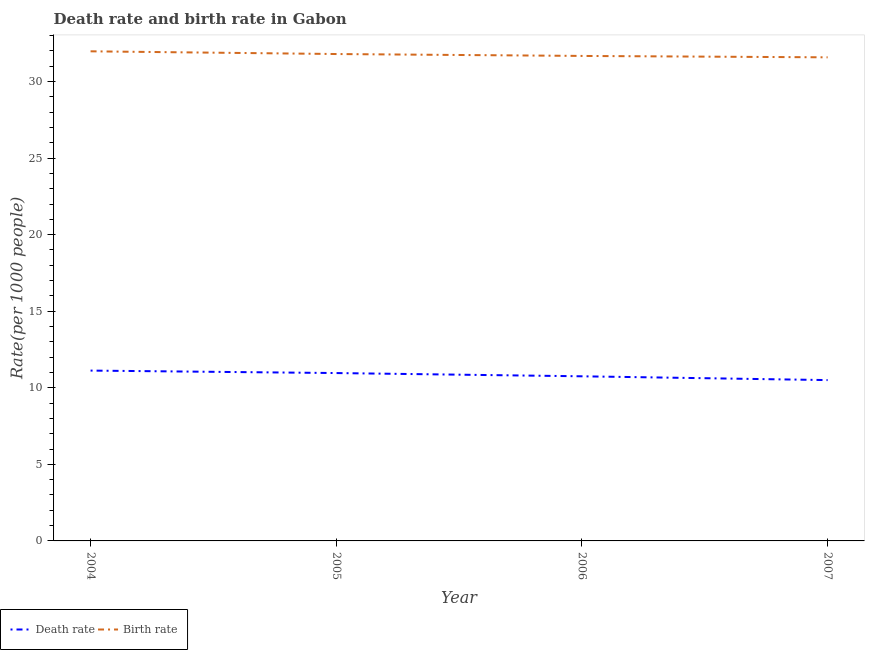How many different coloured lines are there?
Provide a short and direct response. 2. Is the number of lines equal to the number of legend labels?
Make the answer very short. Yes. What is the birth rate in 2006?
Ensure brevity in your answer.  31.67. Across all years, what is the maximum birth rate?
Make the answer very short. 31.98. Across all years, what is the minimum death rate?
Give a very brief answer. 10.5. In which year was the death rate maximum?
Provide a short and direct response. 2004. What is the total death rate in the graph?
Your answer should be very brief. 43.34. What is the difference between the birth rate in 2006 and that in 2007?
Keep it short and to the point. 0.09. What is the difference between the death rate in 2007 and the birth rate in 2005?
Offer a terse response. -21.29. What is the average birth rate per year?
Your answer should be very brief. 31.76. In the year 2004, what is the difference between the birth rate and death rate?
Ensure brevity in your answer.  20.85. In how many years, is the death rate greater than 11?
Make the answer very short. 1. What is the ratio of the death rate in 2005 to that in 2006?
Ensure brevity in your answer.  1.02. Is the death rate in 2004 less than that in 2007?
Provide a short and direct response. No. Is the difference between the birth rate in 2005 and 2007 greater than the difference between the death rate in 2005 and 2007?
Keep it short and to the point. No. What is the difference between the highest and the second highest birth rate?
Offer a terse response. 0.18. What is the difference between the highest and the lowest birth rate?
Your answer should be compact. 0.39. In how many years, is the birth rate greater than the average birth rate taken over all years?
Keep it short and to the point. 2. Is the sum of the death rate in 2004 and 2005 greater than the maximum birth rate across all years?
Keep it short and to the point. No. Does the death rate monotonically increase over the years?
Offer a very short reply. No. Is the birth rate strictly greater than the death rate over the years?
Provide a succinct answer. Yes. Is the birth rate strictly less than the death rate over the years?
Give a very brief answer. No. How many lines are there?
Make the answer very short. 2. How many years are there in the graph?
Provide a succinct answer. 4. Are the values on the major ticks of Y-axis written in scientific E-notation?
Make the answer very short. No. Does the graph contain any zero values?
Make the answer very short. No. Where does the legend appear in the graph?
Your response must be concise. Bottom left. How many legend labels are there?
Your answer should be compact. 2. What is the title of the graph?
Your response must be concise. Death rate and birth rate in Gabon. What is the label or title of the X-axis?
Your answer should be compact. Year. What is the label or title of the Y-axis?
Offer a terse response. Rate(per 1000 people). What is the Rate(per 1000 people) of Death rate in 2004?
Offer a terse response. 11.12. What is the Rate(per 1000 people) of Birth rate in 2004?
Ensure brevity in your answer.  31.98. What is the Rate(per 1000 people) of Death rate in 2005?
Provide a short and direct response. 10.96. What is the Rate(per 1000 people) of Birth rate in 2005?
Your response must be concise. 31.8. What is the Rate(per 1000 people) in Death rate in 2006?
Keep it short and to the point. 10.75. What is the Rate(per 1000 people) of Birth rate in 2006?
Provide a succinct answer. 31.67. What is the Rate(per 1000 people) in Death rate in 2007?
Make the answer very short. 10.5. What is the Rate(per 1000 people) in Birth rate in 2007?
Provide a short and direct response. 31.58. Across all years, what is the maximum Rate(per 1000 people) in Death rate?
Offer a terse response. 11.12. Across all years, what is the maximum Rate(per 1000 people) of Birth rate?
Your answer should be very brief. 31.98. Across all years, what is the minimum Rate(per 1000 people) in Death rate?
Give a very brief answer. 10.5. Across all years, what is the minimum Rate(per 1000 people) in Birth rate?
Offer a terse response. 31.58. What is the total Rate(per 1000 people) of Death rate in the graph?
Your response must be concise. 43.34. What is the total Rate(per 1000 people) of Birth rate in the graph?
Your answer should be very brief. 127.03. What is the difference between the Rate(per 1000 people) of Death rate in 2004 and that in 2005?
Offer a terse response. 0.16. What is the difference between the Rate(per 1000 people) of Birth rate in 2004 and that in 2005?
Keep it short and to the point. 0.18. What is the difference between the Rate(per 1000 people) in Death rate in 2004 and that in 2006?
Give a very brief answer. 0.37. What is the difference between the Rate(per 1000 people) in Birth rate in 2004 and that in 2006?
Provide a succinct answer. 0.3. What is the difference between the Rate(per 1000 people) in Death rate in 2004 and that in 2007?
Ensure brevity in your answer.  0.62. What is the difference between the Rate(per 1000 people) of Birth rate in 2004 and that in 2007?
Give a very brief answer. 0.39. What is the difference between the Rate(per 1000 people) in Death rate in 2005 and that in 2006?
Provide a short and direct response. 0.21. What is the difference between the Rate(per 1000 people) in Death rate in 2005 and that in 2007?
Keep it short and to the point. 0.46. What is the difference between the Rate(per 1000 people) of Birth rate in 2005 and that in 2007?
Make the answer very short. 0.22. What is the difference between the Rate(per 1000 people) in Death rate in 2006 and that in 2007?
Provide a short and direct response. 0.25. What is the difference between the Rate(per 1000 people) in Birth rate in 2006 and that in 2007?
Keep it short and to the point. 0.09. What is the difference between the Rate(per 1000 people) in Death rate in 2004 and the Rate(per 1000 people) in Birth rate in 2005?
Your response must be concise. -20.67. What is the difference between the Rate(per 1000 people) of Death rate in 2004 and the Rate(per 1000 people) of Birth rate in 2006?
Offer a very short reply. -20.55. What is the difference between the Rate(per 1000 people) in Death rate in 2004 and the Rate(per 1000 people) in Birth rate in 2007?
Give a very brief answer. -20.46. What is the difference between the Rate(per 1000 people) of Death rate in 2005 and the Rate(per 1000 people) of Birth rate in 2006?
Ensure brevity in your answer.  -20.71. What is the difference between the Rate(per 1000 people) of Death rate in 2005 and the Rate(per 1000 people) of Birth rate in 2007?
Provide a short and direct response. -20.62. What is the difference between the Rate(per 1000 people) of Death rate in 2006 and the Rate(per 1000 people) of Birth rate in 2007?
Offer a terse response. -20.83. What is the average Rate(per 1000 people) of Death rate per year?
Give a very brief answer. 10.84. What is the average Rate(per 1000 people) in Birth rate per year?
Make the answer very short. 31.76. In the year 2004, what is the difference between the Rate(per 1000 people) of Death rate and Rate(per 1000 people) of Birth rate?
Provide a succinct answer. -20.85. In the year 2005, what is the difference between the Rate(per 1000 people) in Death rate and Rate(per 1000 people) in Birth rate?
Ensure brevity in your answer.  -20.84. In the year 2006, what is the difference between the Rate(per 1000 people) in Death rate and Rate(per 1000 people) in Birth rate?
Your answer should be very brief. -20.92. In the year 2007, what is the difference between the Rate(per 1000 people) of Death rate and Rate(per 1000 people) of Birth rate?
Ensure brevity in your answer.  -21.08. What is the ratio of the Rate(per 1000 people) of Death rate in 2004 to that in 2005?
Offer a terse response. 1.01. What is the ratio of the Rate(per 1000 people) of Birth rate in 2004 to that in 2005?
Give a very brief answer. 1.01. What is the ratio of the Rate(per 1000 people) of Death rate in 2004 to that in 2006?
Offer a very short reply. 1.03. What is the ratio of the Rate(per 1000 people) in Birth rate in 2004 to that in 2006?
Keep it short and to the point. 1.01. What is the ratio of the Rate(per 1000 people) in Death rate in 2004 to that in 2007?
Ensure brevity in your answer.  1.06. What is the ratio of the Rate(per 1000 people) of Birth rate in 2004 to that in 2007?
Provide a short and direct response. 1.01. What is the ratio of the Rate(per 1000 people) of Death rate in 2005 to that in 2006?
Give a very brief answer. 1.02. What is the ratio of the Rate(per 1000 people) of Death rate in 2005 to that in 2007?
Provide a succinct answer. 1.04. What is the ratio of the Rate(per 1000 people) in Birth rate in 2005 to that in 2007?
Offer a very short reply. 1.01. What is the ratio of the Rate(per 1000 people) of Death rate in 2006 to that in 2007?
Provide a short and direct response. 1.02. What is the ratio of the Rate(per 1000 people) of Birth rate in 2006 to that in 2007?
Ensure brevity in your answer.  1. What is the difference between the highest and the second highest Rate(per 1000 people) of Death rate?
Your answer should be compact. 0.16. What is the difference between the highest and the second highest Rate(per 1000 people) in Birth rate?
Your answer should be compact. 0.18. What is the difference between the highest and the lowest Rate(per 1000 people) of Death rate?
Keep it short and to the point. 0.62. What is the difference between the highest and the lowest Rate(per 1000 people) in Birth rate?
Make the answer very short. 0.39. 